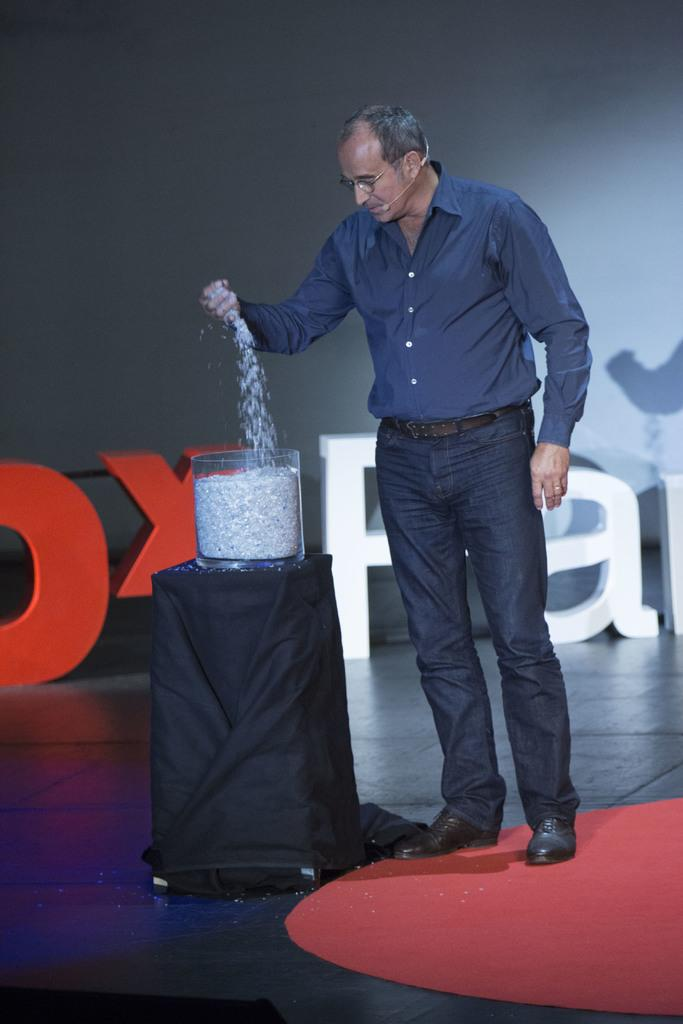What is the main subject of the image? There is a man standing in the center of the image. What is the man doing in the image? The man is pouring something into a beaker. Where is the beaker located in the image? The beaker is placed on a stand. What can be seen in the background of the image? There is a board in the background of the image. What type of meal is the man preparing in the image? There is no indication in the image that the man is preparing a meal; he is pouring something into a beaker. What is the reaction of the beaker to the substance being poured into it? The beaker is an inanimate object and does not have a reaction; it is simply holding the substance being poured into it. 